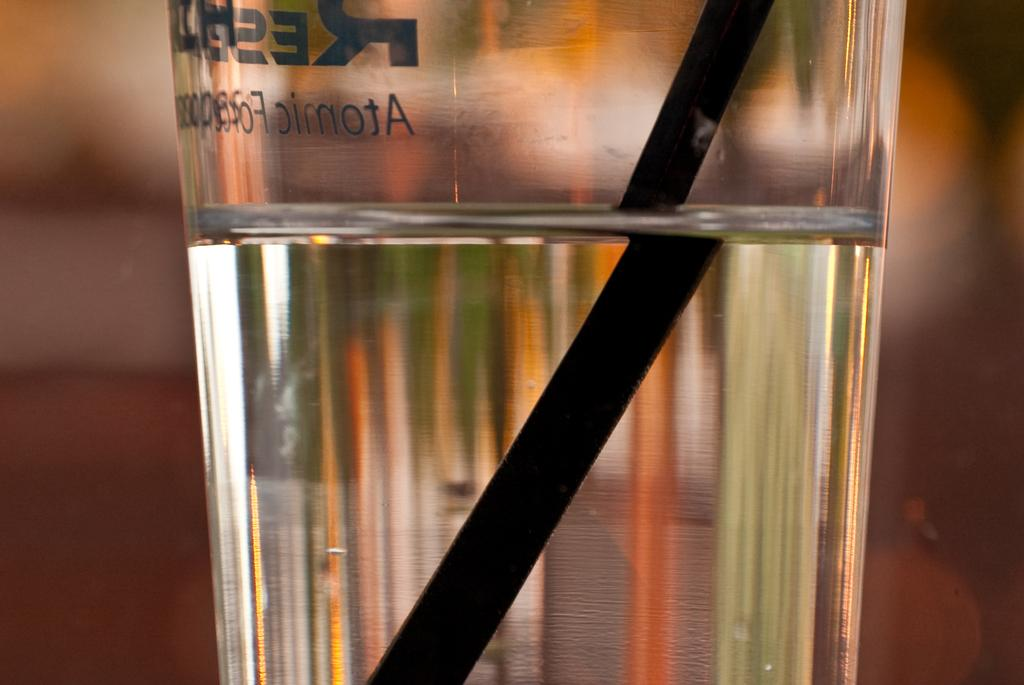<image>
Present a compact description of the photo's key features. A glass of clear liquid with a black straw says Atomic on it. 